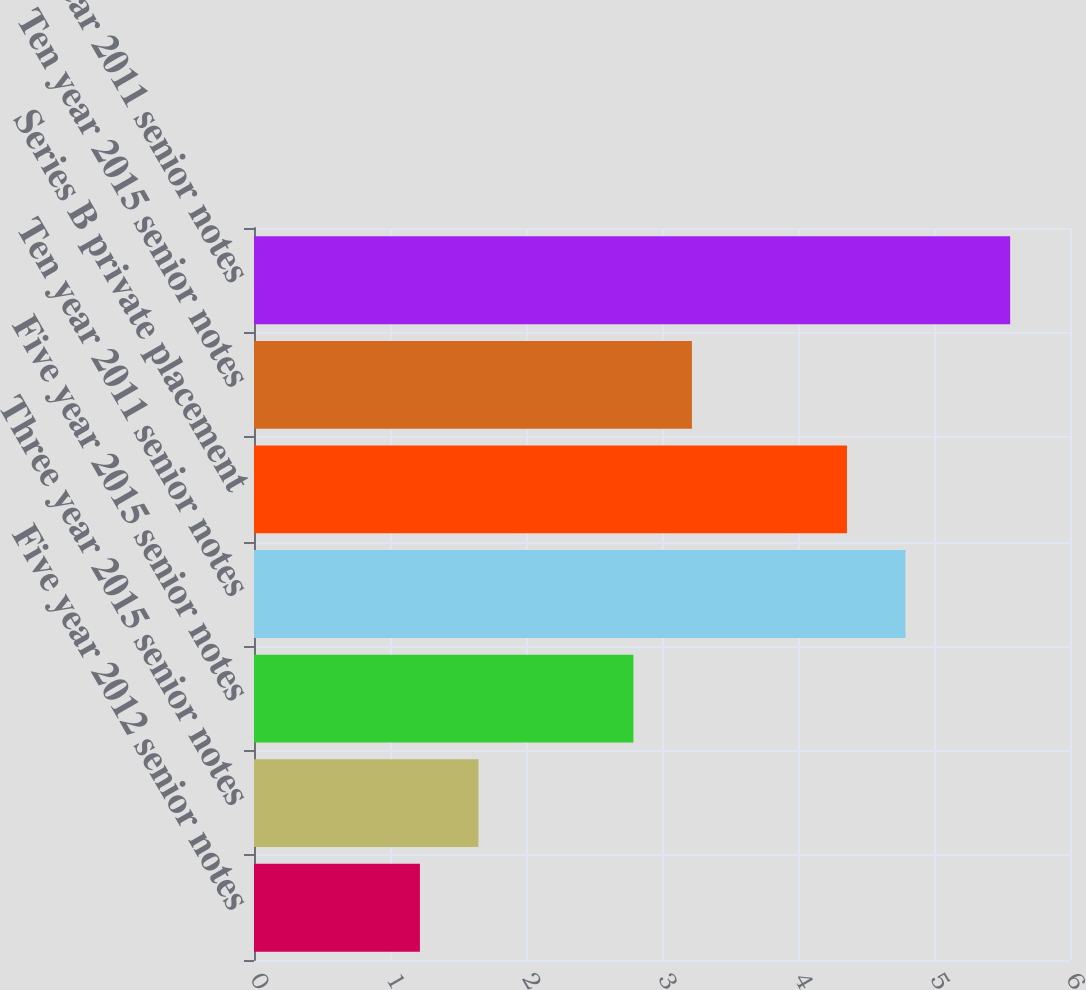Convert chart to OTSL. <chart><loc_0><loc_0><loc_500><loc_500><bar_chart><fcel>Five year 2012 senior notes<fcel>Three year 2015 senior notes<fcel>Five year 2015 senior notes<fcel>Ten year 2011 senior notes<fcel>Series B private placement<fcel>Ten year 2015 senior notes<fcel>Thirty year 2011 senior notes<nl><fcel>1.22<fcel>1.65<fcel>2.79<fcel>4.79<fcel>4.36<fcel>3.22<fcel>5.56<nl></chart> 